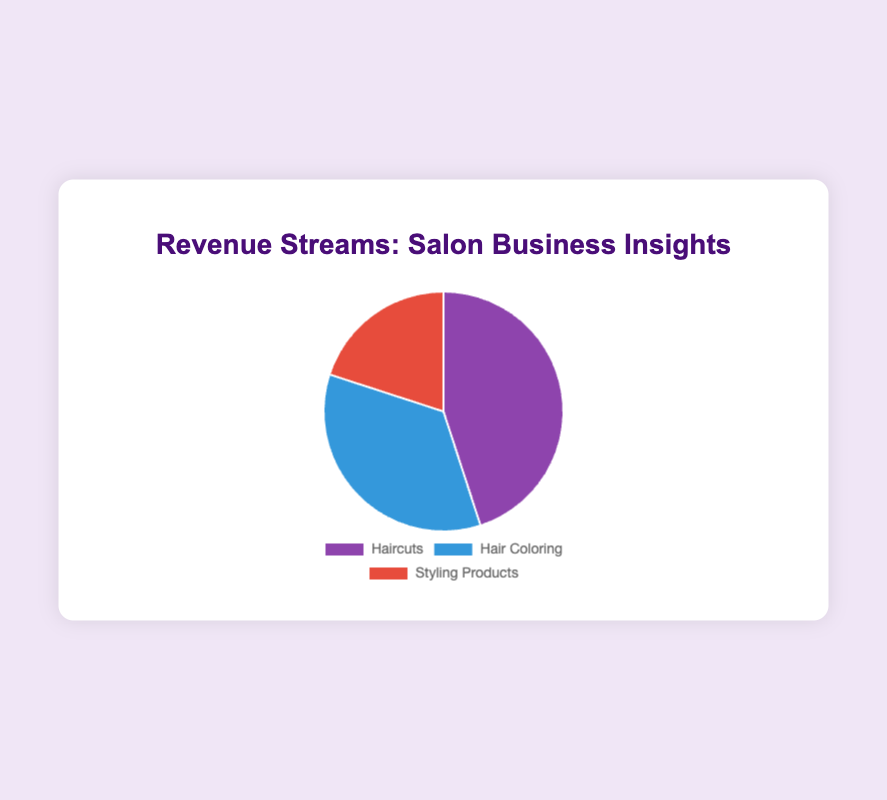What percentage of the total revenue comes from Haircuts? First, sum up the total revenue from all categories: 45000 (Haircuts) + 35000 (Hair Coloring) + 20000 (Styling Products) = 100000. Then, calculate the percentage contribution of Haircuts: (45000 / 100000) * 100 = 45%.
Answer: 45% Which category has the lowest earnings? Compare the earnings of all categories: Haircuts (45000), Hair Coloring (35000), and Styling Products (20000). The lowest earnings belong to Styling Products.
Answer: Styling Products How much more revenue is earned from Hair Coloring compared to Styling Products? Subtract the earnings of Styling Products from Hair Coloring: 35000 (Hair Coloring) - 20000 (Styling Products) = 15000.
Answer: 15000 What is the ratio of the earnings from Haircuts to Hair Coloring? Divide the earnings of Haircuts by the earnings of Hair Coloring: 45000 (Haircuts) / 35000 (Hair Coloring) = 1.29.
Answer: 1.29 If the earnings from Styling Products increased by 50%, what would be the new total revenue? First, calculate the new earnings for Styling Products: 20000 * 1.5 = 30000. Then, sum up the new total revenue: 45000 (Haircuts) + 35000 (Hair Coloring) + 30000 (Updated Styling Products) = 110000.
Answer: 110000 Which category is visually represented by the largest segment in the pie chart? The largest segment corresponds to the category with the highest earnings, which is Haircuts with 45000 USD.
Answer: Haircuts What is the difference between the earnings of the two highest-earning categories? The two highest-earning categories are Haircuts (45000) and Hair Coloring (35000). Subtract the earnings of Hair Coloring from Haircuts: 45000 - 35000 = 10000.
Answer: 10000 What percentage of the total revenue is earned from Hair Coloring and Styling Products combined? First, sum up the earnings from Hair Coloring and Styling Products: 35000 + 20000 = 55000. Then, calculate the percentage contribution: (55000 / 100000) * 100 = 55%.
Answer: 55% If the salon wants at least 50% of its revenue to come from Haircuts, how much additional revenue should they generate from Haircuts? First, determine the revenue target for Haircuts: 50% of 100000 (total revenue) = 50000. The additional revenue needed is: 50000 - 45000 = 5000.
Answer: 5000 